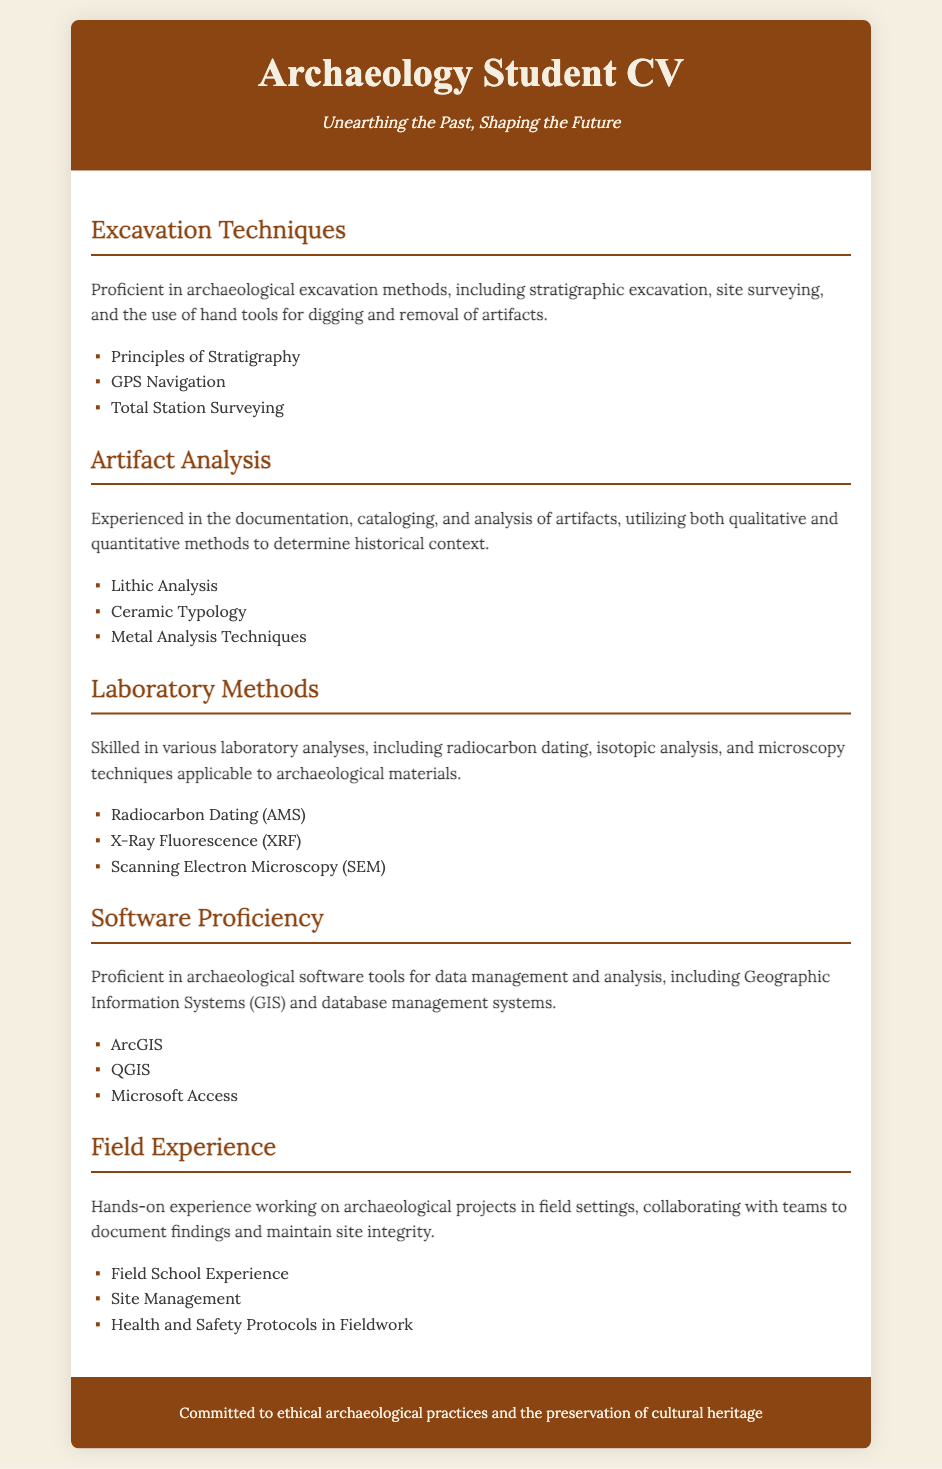what are the excavation techniques mentioned? The document lists specific excavation techniques employed by the archaeology student, providing examples from the skill section.
Answer: stratigraphic excavation, site surveying, hand tools which software is used for Geographic Information Systems? The document states the software proficiency section highlights specific tools used by the student for GIS.
Answer: ArcGIS, QGIS how many laboratory analysis techniques are listed? The laboratory methods section details various analytical techniques, allowing for a count of the mentioned methods.
Answer: three what type of analysis is conducted with X-Ray Fluorescence? The document indicates the laboratory methods that include specific types of analysis associated with archaeological materials.
Answer: isotopic analysis which area requires health and safety protocols? The field experience section emphasizes the importance of safety measures during fieldwork, outlining necessary protocols.
Answer: Fieldwork what is the subtitle of the CV? The document includes a subtitle under the main title, providing additional context about the student's ambition in archaeology.
Answer: Unearthing the Past, Shaping the Future how many artifact analysis methods are there? The artifact analysis section provides a list of methods, thus allowing a count of how many are mentioned.
Answer: three what background is given in the footer? The footer of the document conveys the author's values and commitment towards the ethical practice in archaeology.
Answer: ethical archaeological practices and the preservation of cultural heritage 